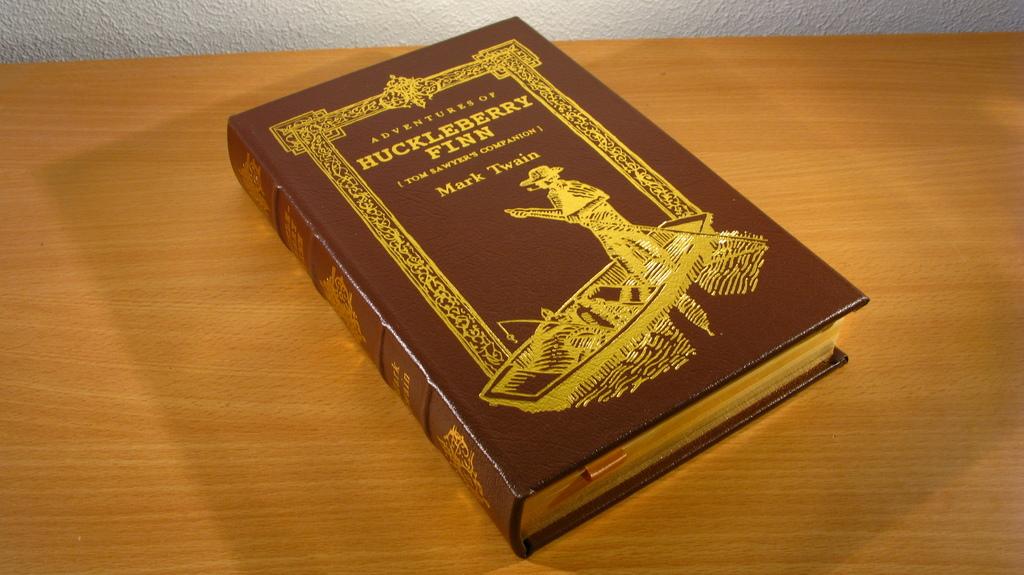Who is pictured on the cover of the book?
Make the answer very short. Huckleberry finn. Who wrote the book?
Keep it short and to the point. Mark twain. 